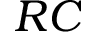Convert formula to latex. <formula><loc_0><loc_0><loc_500><loc_500>R C</formula> 